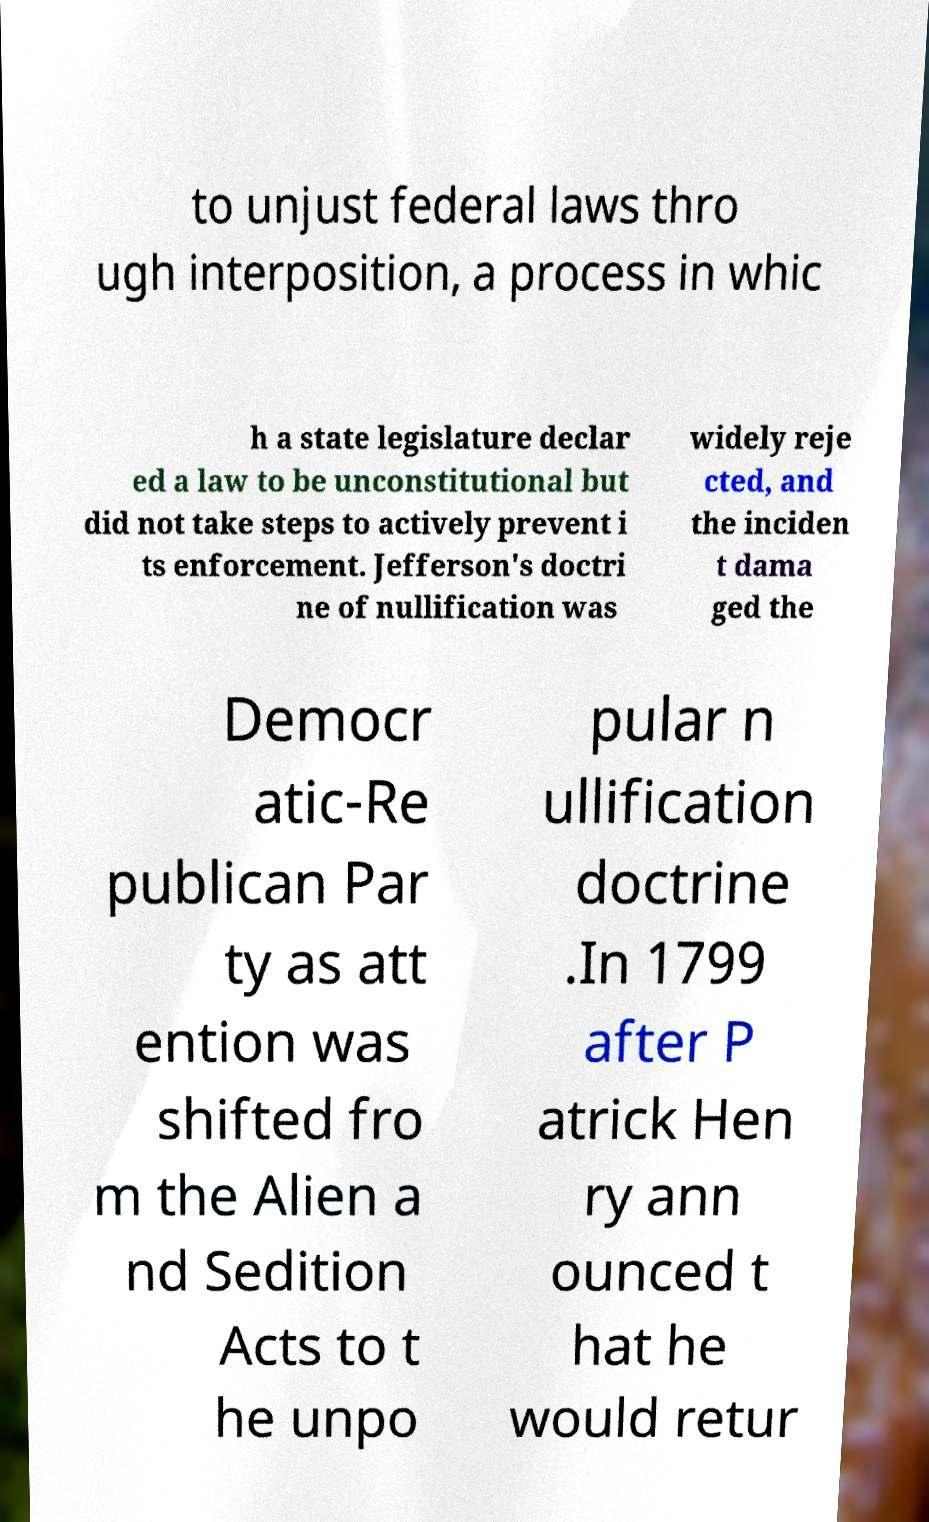Could you assist in decoding the text presented in this image and type it out clearly? to unjust federal laws thro ugh interposition, a process in whic h a state legislature declar ed a law to be unconstitutional but did not take steps to actively prevent i ts enforcement. Jefferson's doctri ne of nullification was widely reje cted, and the inciden t dama ged the Democr atic-Re publican Par ty as att ention was shifted fro m the Alien a nd Sedition Acts to t he unpo pular n ullification doctrine .In 1799 after P atrick Hen ry ann ounced t hat he would retur 